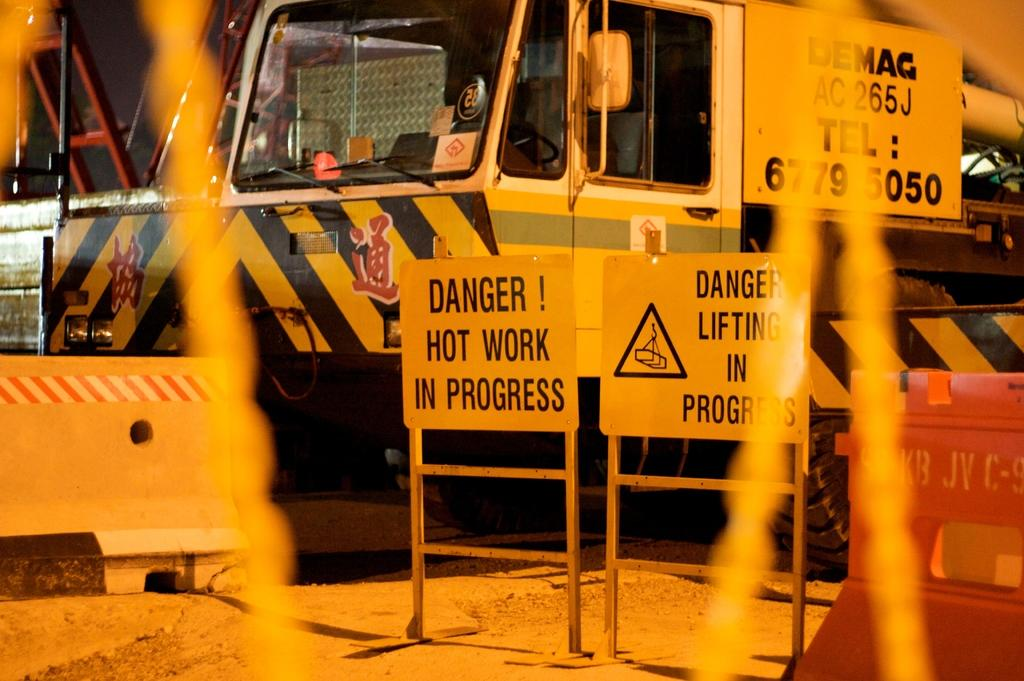<image>
Summarize the visual content of the image. The warning signs let others know there is danger and work in progress. 